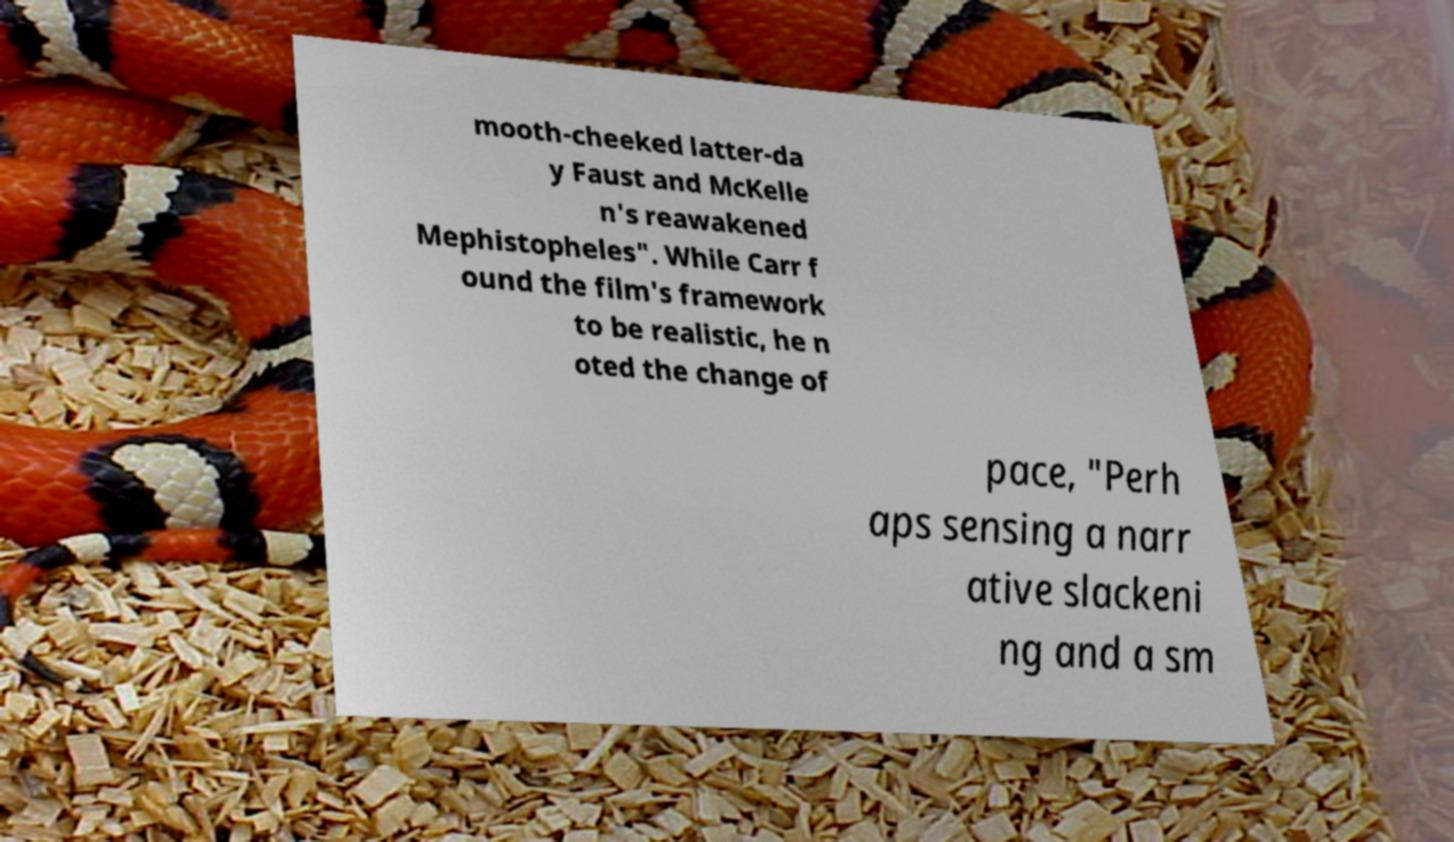Could you extract and type out the text from this image? mooth-cheeked latter-da y Faust and McKelle n's reawakened Mephistopheles". While Carr f ound the film's framework to be realistic, he n oted the change of pace, "Perh aps sensing a narr ative slackeni ng and a sm 